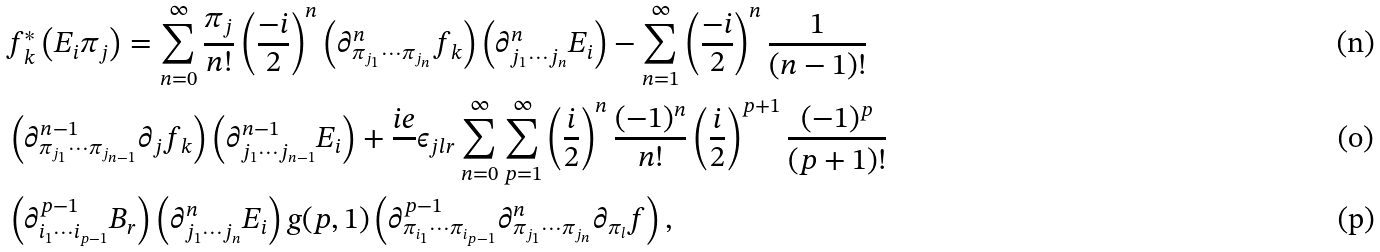<formula> <loc_0><loc_0><loc_500><loc_500>& f _ { k } ^ { * } \left ( E _ { i } \pi _ { j } \right ) = \sum _ { n = 0 } ^ { \infty } \frac { \pi _ { j } } { n ! } \left ( \frac { - i } { 2 } \right ) ^ { n } \left ( \partial _ { \pi _ { j _ { 1 } } \cdots \pi _ { j _ { n } } } ^ { n } f _ { k } \right ) \left ( \partial _ { j _ { 1 } \cdots j _ { n } } ^ { n } E _ { i } \right ) - \sum _ { n = 1 } ^ { \infty } \left ( \frac { - i } { 2 } \right ) ^ { n } \frac { 1 } { ( n - 1 ) ! } \\ & \left ( \partial _ { \pi _ { j _ { 1 } } \cdots \pi _ { j _ { n - 1 } } } ^ { n - 1 } \partial _ { j } f _ { k } \right ) \left ( \partial _ { j _ { 1 } \cdots j _ { n - 1 } } ^ { n - 1 } E _ { i } \right ) + \frac { i e } { } \epsilon _ { j l r } \sum _ { n = 0 } ^ { \infty } \sum _ { p = 1 } ^ { \infty } \left ( \frac { i } { 2 } \right ) ^ { n } \frac { ( - 1 ) ^ { n } } { n ! } \left ( \frac { i } { 2 } \right ) ^ { p + 1 } \frac { ( - 1 ) ^ { p } } { ( p + 1 ) ! } \\ & \left ( \partial _ { i _ { 1 } \cdots i _ { p - 1 } } ^ { p - 1 } B _ { r } \right ) \left ( \partial _ { j _ { 1 } \cdots j _ { n } } ^ { n } E _ { i } \right ) g ( p , 1 ) \left ( \partial _ { \pi _ { i _ { 1 } } \cdots \pi _ { i _ { p - 1 } } } ^ { p - 1 } \partial _ { \pi _ { j _ { 1 } } \cdots \pi _ { j _ { n } } } ^ { n } \partial _ { \pi _ { l } } f \right ) ,</formula> 